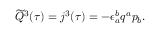<formula> <loc_0><loc_0><loc_500><loc_500>\widetilde { Q } ^ { 3 } ( \tau ) = j ^ { 3 } ( \tau ) = - \epsilon _ { a } ^ { b } q ^ { a } p _ { b } .</formula> 